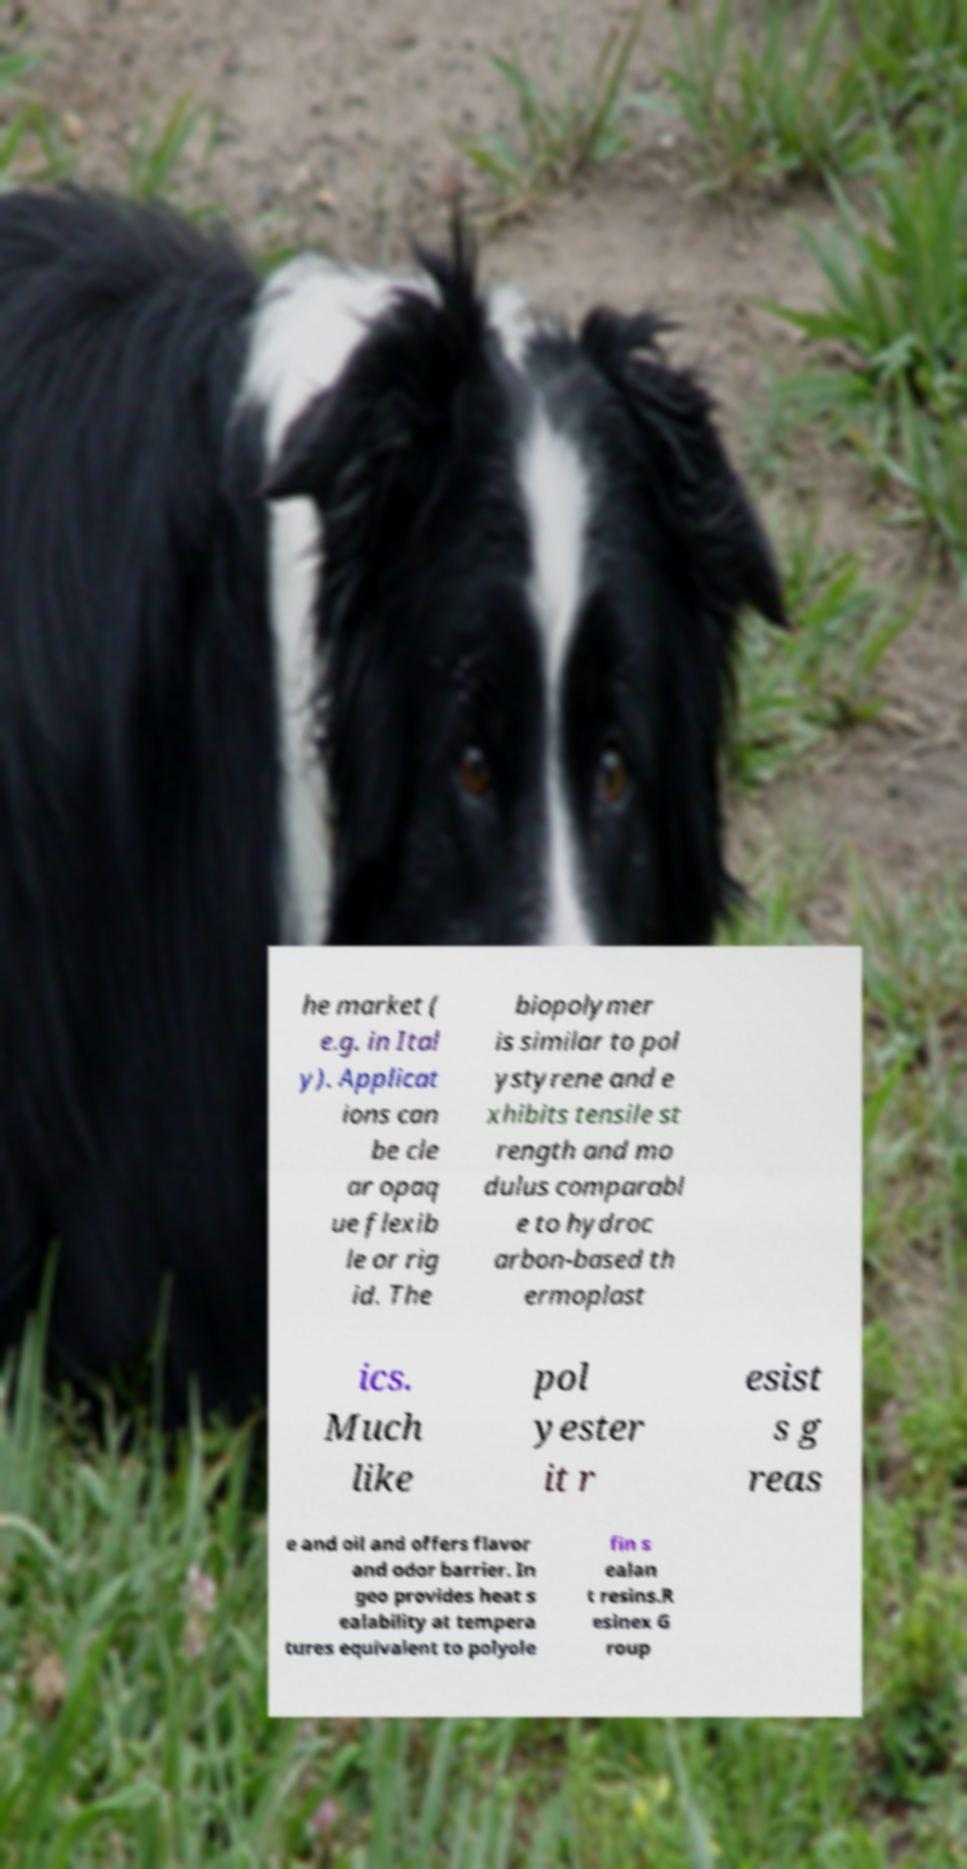Can you accurately transcribe the text from the provided image for me? he market ( e.g. in Ital y). Applicat ions can be cle ar opaq ue flexib le or rig id. The biopolymer is similar to pol ystyrene and e xhibits tensile st rength and mo dulus comparabl e to hydroc arbon-based th ermoplast ics. Much like pol yester it r esist s g reas e and oil and offers flavor and odor barrier. In geo provides heat s ealability at tempera tures equivalent to polyole fin s ealan t resins.R esinex G roup 